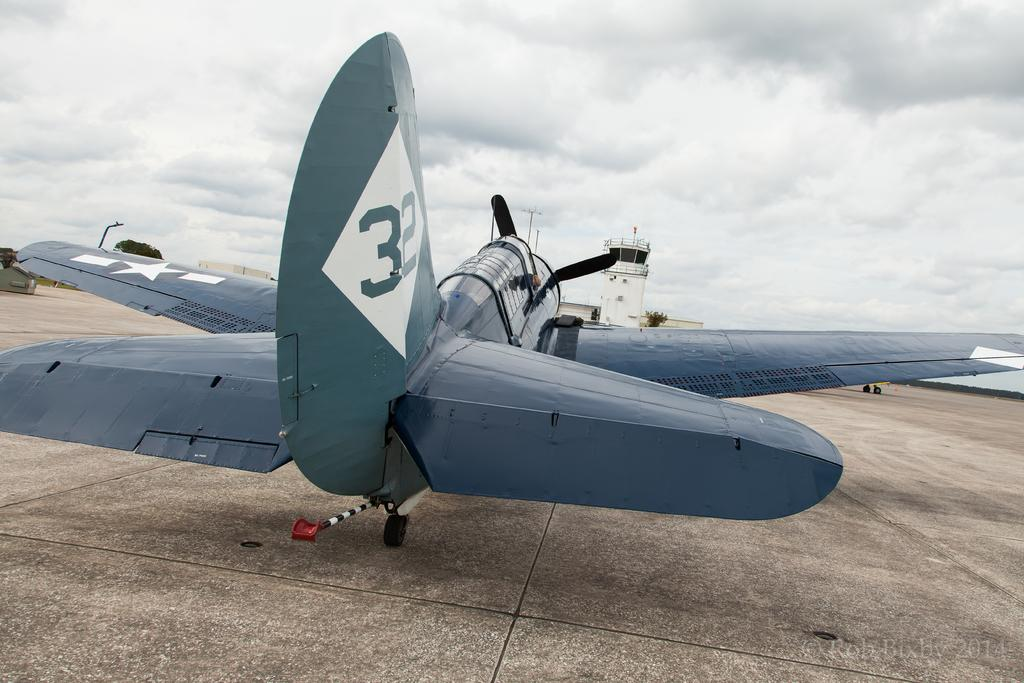What is the main subject of the picture? The main subject of the picture is an aircraft. What are the main features of the aircraft? The aircraft has wings and wheels. Can you describe the interior of the aircraft? There is a cabin in the aircraft. What can be seen in the background of the picture? There is a building and a tree in the background of the picture. How is the weather in the image? The sky is clear in the image. What type of way can be seen in the image? There is no way present in the image; it features an aircraft with a clear sky in the background. Is there any smoke coming out of the aircraft in the image? There is no smoke coming out of the aircraft in the image. 